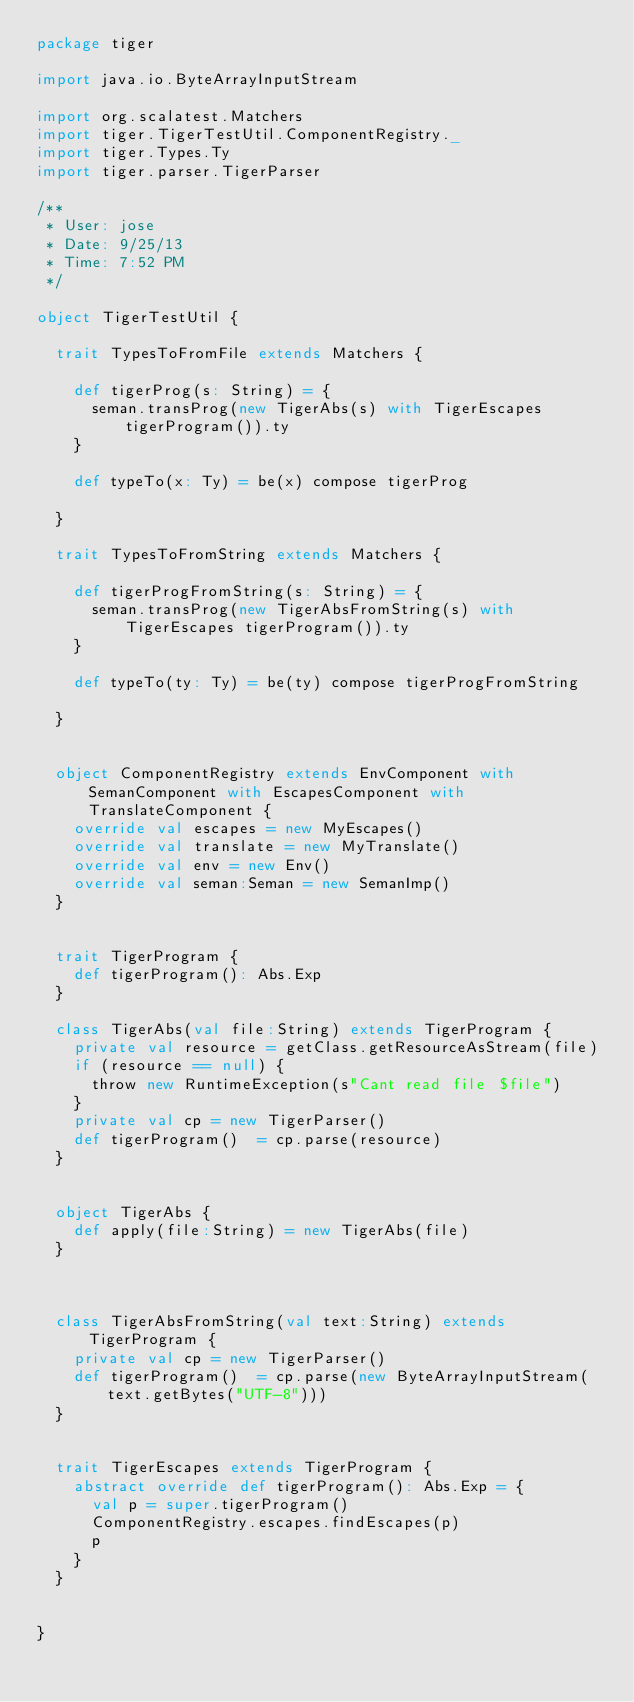Convert code to text. <code><loc_0><loc_0><loc_500><loc_500><_Scala_>package tiger

import java.io.ByteArrayInputStream

import org.scalatest.Matchers
import tiger.TigerTestUtil.ComponentRegistry._
import tiger.Types.Ty
import tiger.parser.TigerParser

/**
 * User: jose
 * Date: 9/25/13
 * Time: 7:52 PM
 */

object TigerTestUtil {

  trait TypesToFromFile extends Matchers {

    def tigerProg(s: String) = {
      seman.transProg(new TigerAbs(s) with TigerEscapes tigerProgram()).ty
    }

    def typeTo(x: Ty) = be(x) compose tigerProg

  }

  trait TypesToFromString extends Matchers {

    def tigerProgFromString(s: String) = {
      seman.transProg(new TigerAbsFromString(s) with TigerEscapes tigerProgram()).ty
    }

    def typeTo(ty: Ty) = be(ty) compose tigerProgFromString

  }


  object ComponentRegistry extends EnvComponent with SemanComponent with EscapesComponent with TranslateComponent {
    override val escapes = new MyEscapes()
    override val translate = new MyTranslate()
    override val env = new Env()
    override val seman:Seman = new SemanImp()
  }


  trait TigerProgram {
    def tigerProgram(): Abs.Exp
  }

  class TigerAbs(val file:String) extends TigerProgram {
    private val resource = getClass.getResourceAsStream(file)
    if (resource == null) {
      throw new RuntimeException(s"Cant read file $file")
    }
    private val cp = new TigerParser()
    def tigerProgram()  = cp.parse(resource)
  }


  object TigerAbs {
    def apply(file:String) = new TigerAbs(file)
  }



  class TigerAbsFromString(val text:String) extends TigerProgram {
    private val cp = new TigerParser()
    def tigerProgram()  = cp.parse(new ByteArrayInputStream(text.getBytes("UTF-8")))
  }


  trait TigerEscapes extends TigerProgram {
    abstract override def tigerProgram(): Abs.Exp = {
      val p = super.tigerProgram()
      ComponentRegistry.escapes.findEscapes(p)
      p
    }
  }


}
</code> 